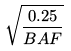Convert formula to latex. <formula><loc_0><loc_0><loc_500><loc_500>\sqrt { \frac { 0 . 2 5 } { B A F } }</formula> 